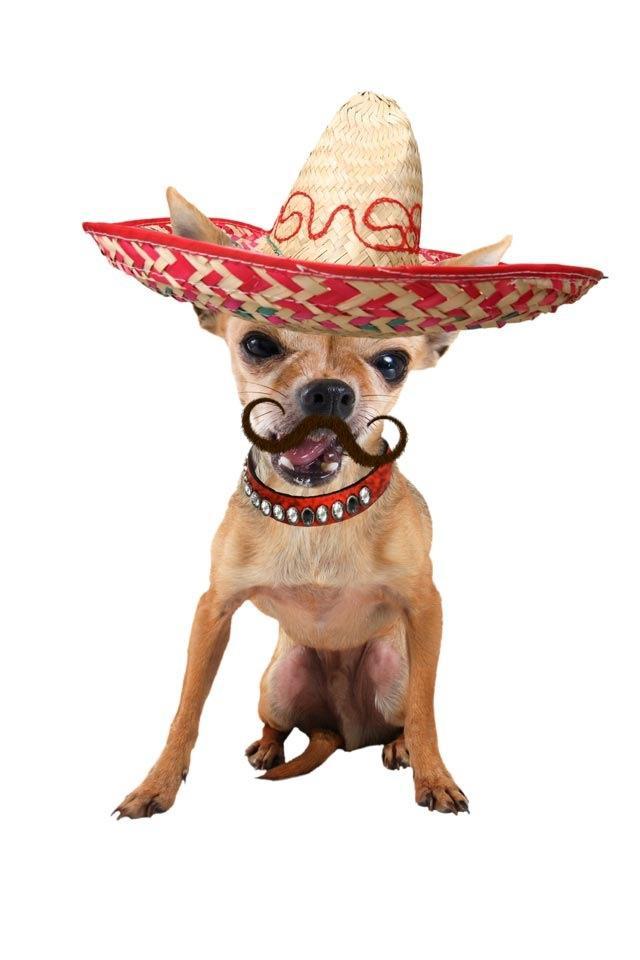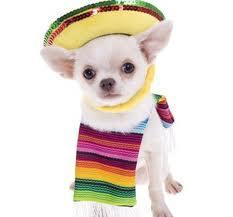The first image is the image on the left, the second image is the image on the right. For the images shown, is this caption "There are two chihuahuas wearing sombreros on top of their heads." true? Answer yes or no. Yes. The first image is the image on the left, the second image is the image on the right. For the images displayed, is the sentence "Each image shows a chihuahua dog wearing a sombrero on top of its head." factually correct? Answer yes or no. Yes. 